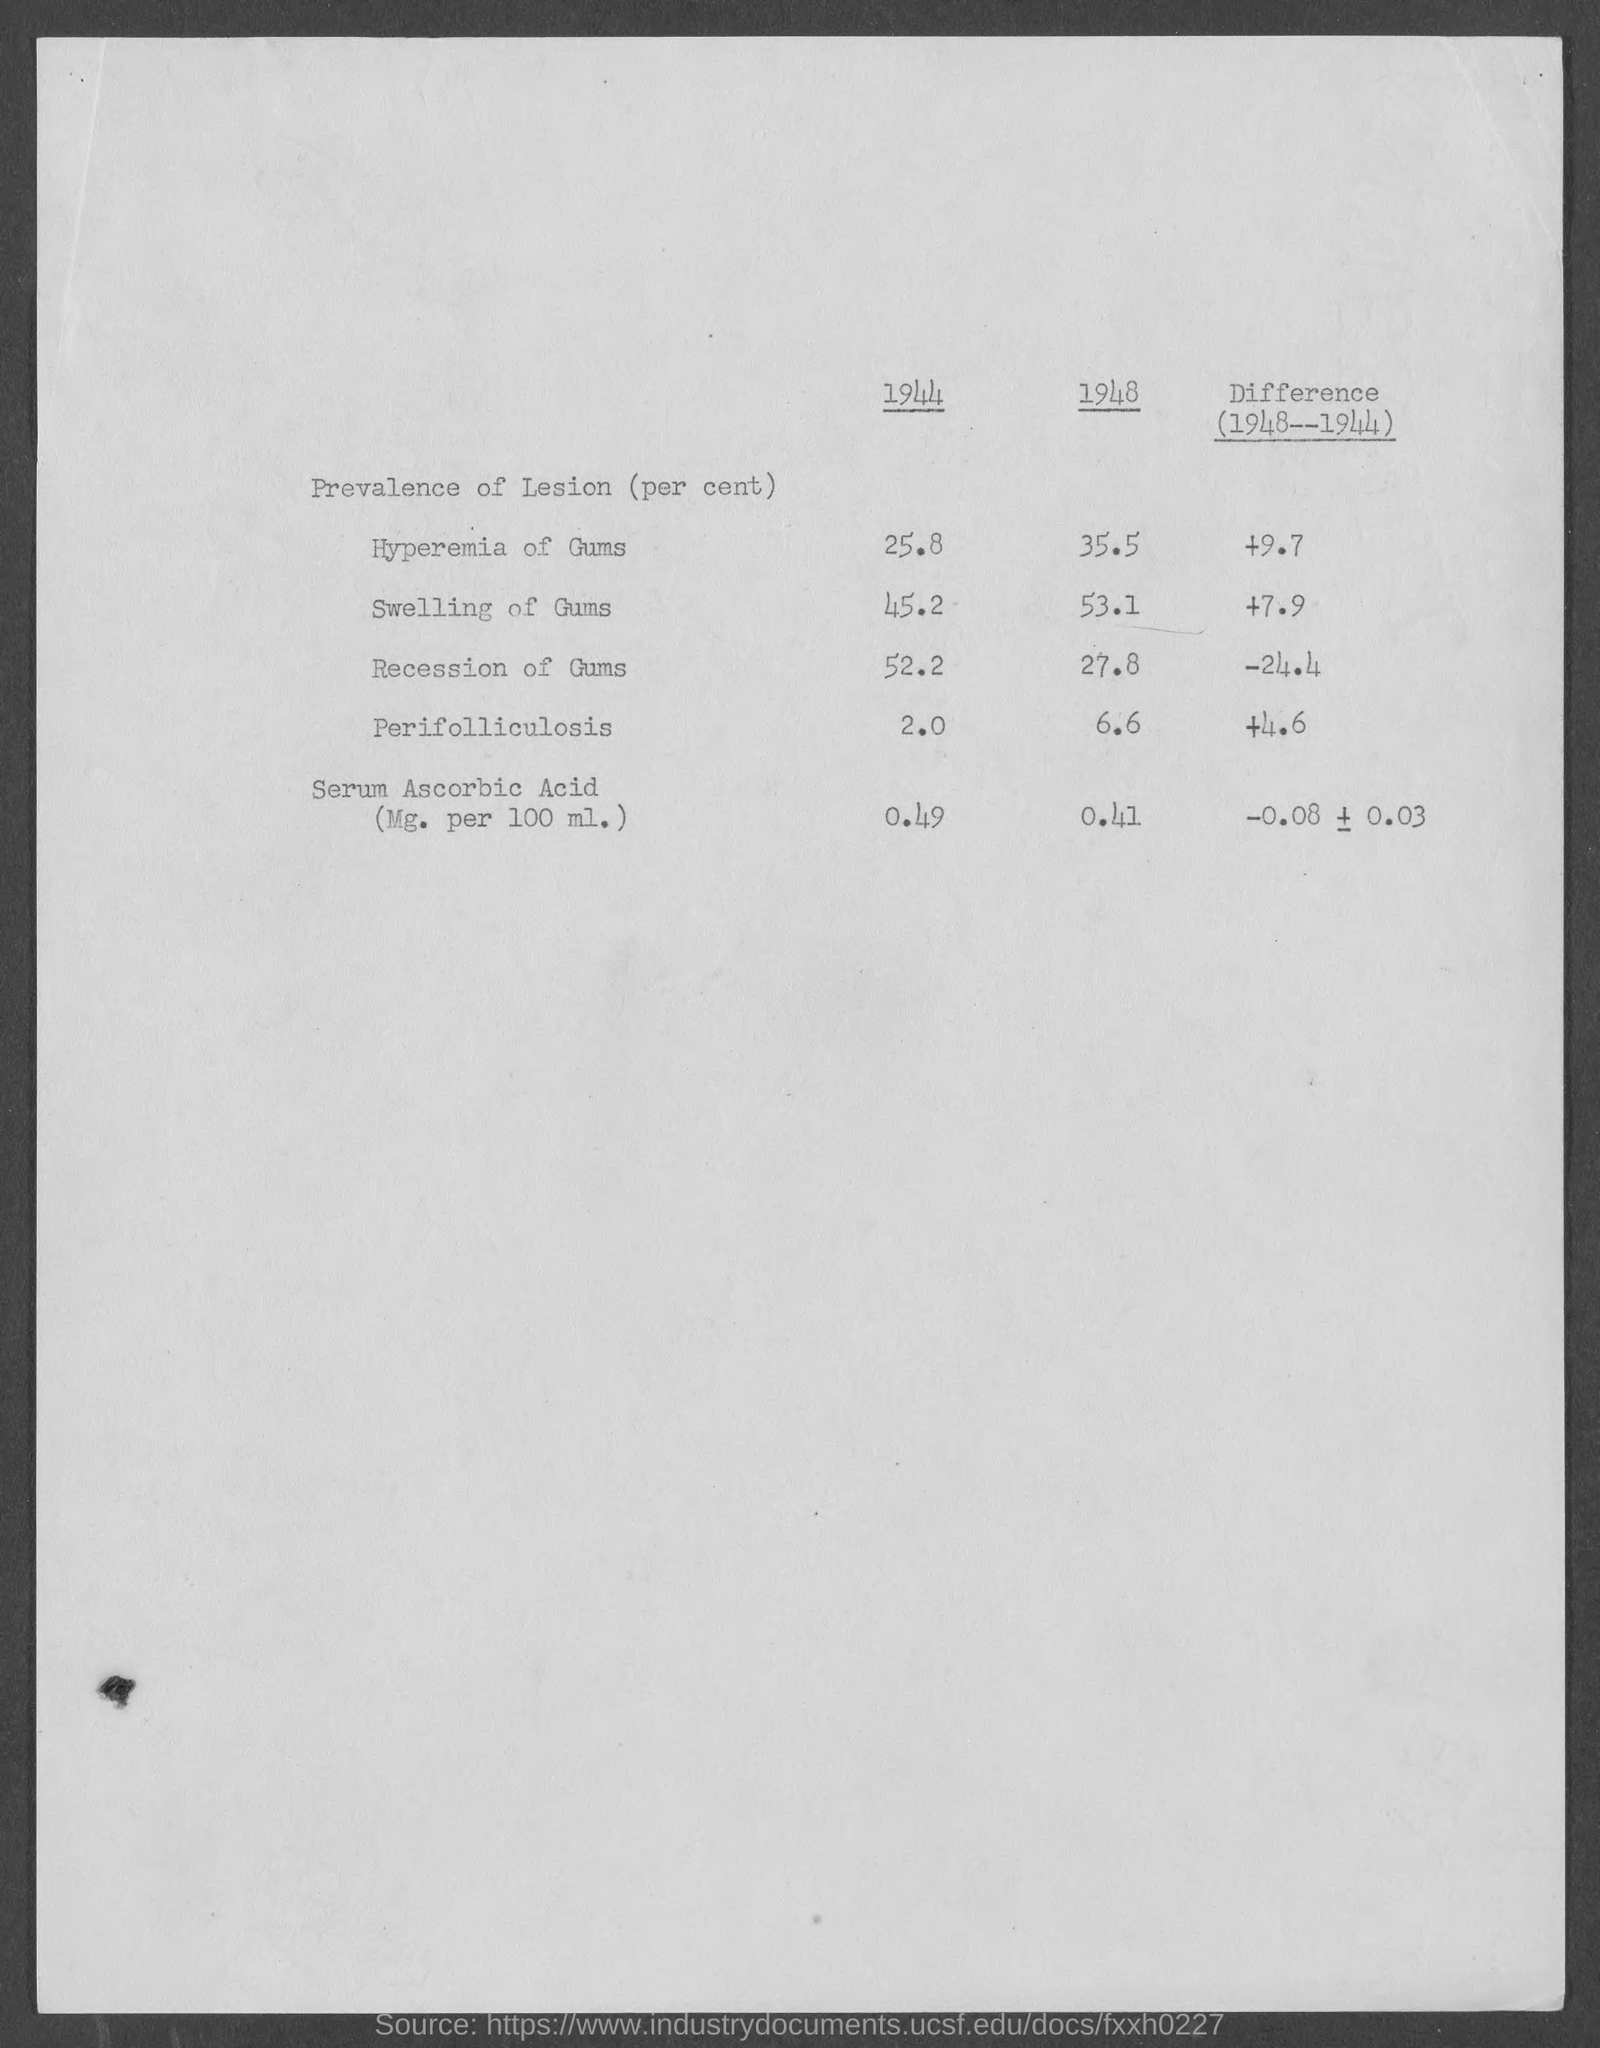Mention a couple of crucial points in this snapshot. The prevalence of lesions in Serum Ascorbic Acid in the year 1948 was 0.41%. In 1944, the prevalence of lesions in hyperemia of gums was found to be 25.8%. The prevalence of lesions in the recession of gums was found to be significantly lower in 1944 compared to 1948, with a difference of -24.4%. In the year 1948, the prevalence of lesions in Perifolliculosis was 6.6%. 